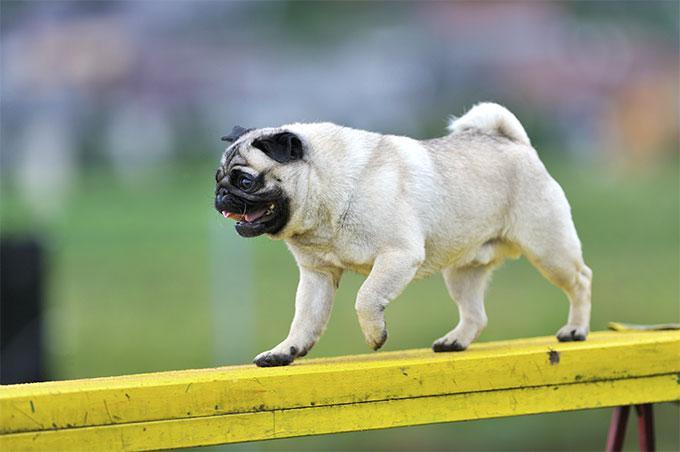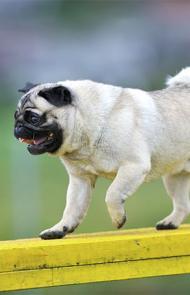The first image is the image on the left, the second image is the image on the right. Given the left and right images, does the statement "A small dark-faced dog has a stick in its mouth and is standing in a field." hold true? Answer yes or no. No. 